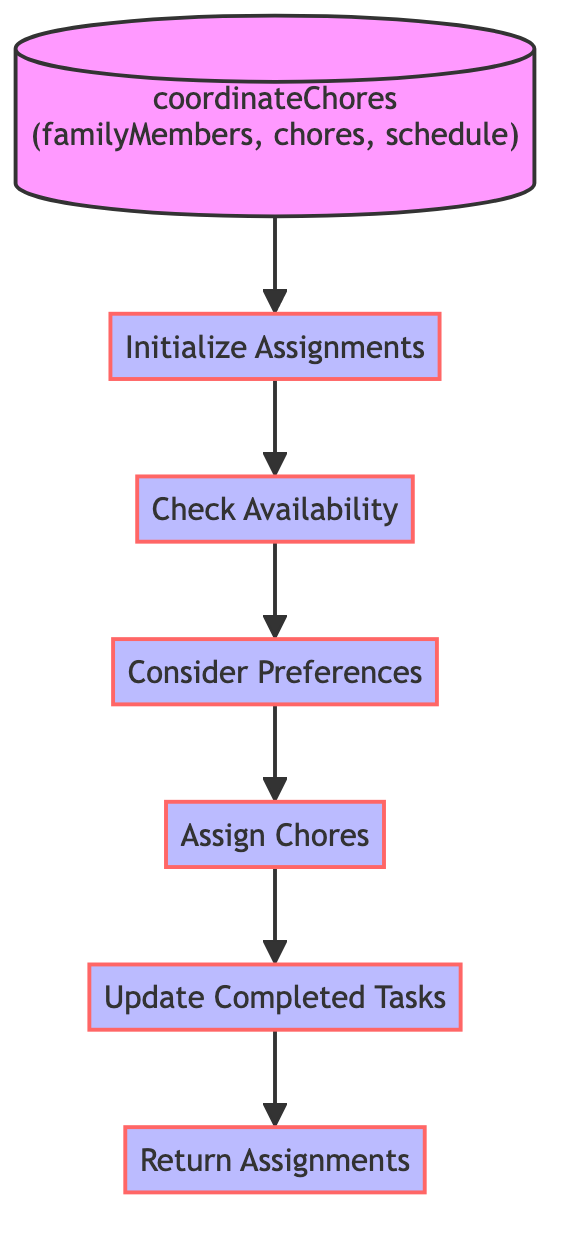What is the function name of the diagram? The diagram clearly displays the name of the function at the top, which is "coordinateChores".
Answer: coordinateChores How many variables are used in the function? The flowchart indicates that there are four variables defined: availability, preferences, assignments, and completedTasks.
Answer: 4 What is the first step in the process? According to the flowchart, the first step listed under the process is "initializeAssignments".
Answer: initializeAssignments What do family members check in the second step? The second step labeled "checkAvailability" indicates that the family members check their "availability" based on the schedule.
Answer: availability Which step directly leads to assigning chores? The step "considerPreferences" leads directly to the step "assignChores" according to the flowchart, indicating that preferences must be evaluated before chores are assigned.
Answer: considerPreferences What is the final output of the function? The diagram shows that the last step ends with "returnAssignments", which reveals that the output of the function is the assignments dictionary.
Answer: assignments What comes after updating completed tasks? The flowchart indicates that "returnAssignments" follows after the "updateCompletedTasks" step.
Answer: returnAssignments Identify a step that involves checking family members’ choices. The step "considerPreferences" explicitly signifies that family members’ preferences for chores are evaluated.
Answer: considerPreferences How many steps are present in the function? The flowchart illustrates a total of six steps defining the process in this function.
Answer: 6 